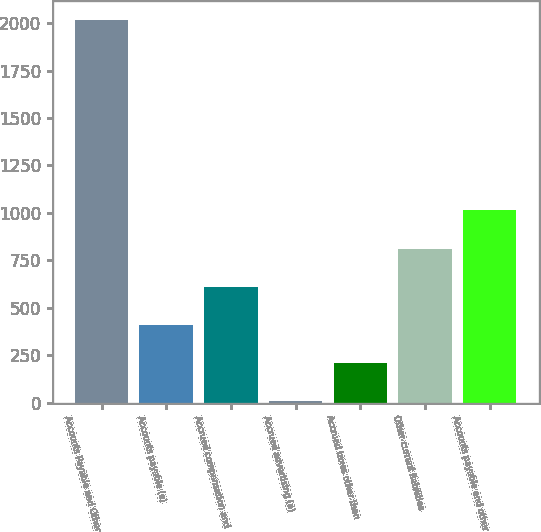Convert chart. <chart><loc_0><loc_0><loc_500><loc_500><bar_chart><fcel>Accounts Payable and Other<fcel>Accounts payable (a)<fcel>Accrued compensation and<fcel>Accrued advertising (a)<fcel>Accrued taxes other than<fcel>Other current liabilities<fcel>Accounts payable and other<nl><fcel>2017<fcel>410.6<fcel>611.4<fcel>9<fcel>209.8<fcel>812.2<fcel>1013<nl></chart> 